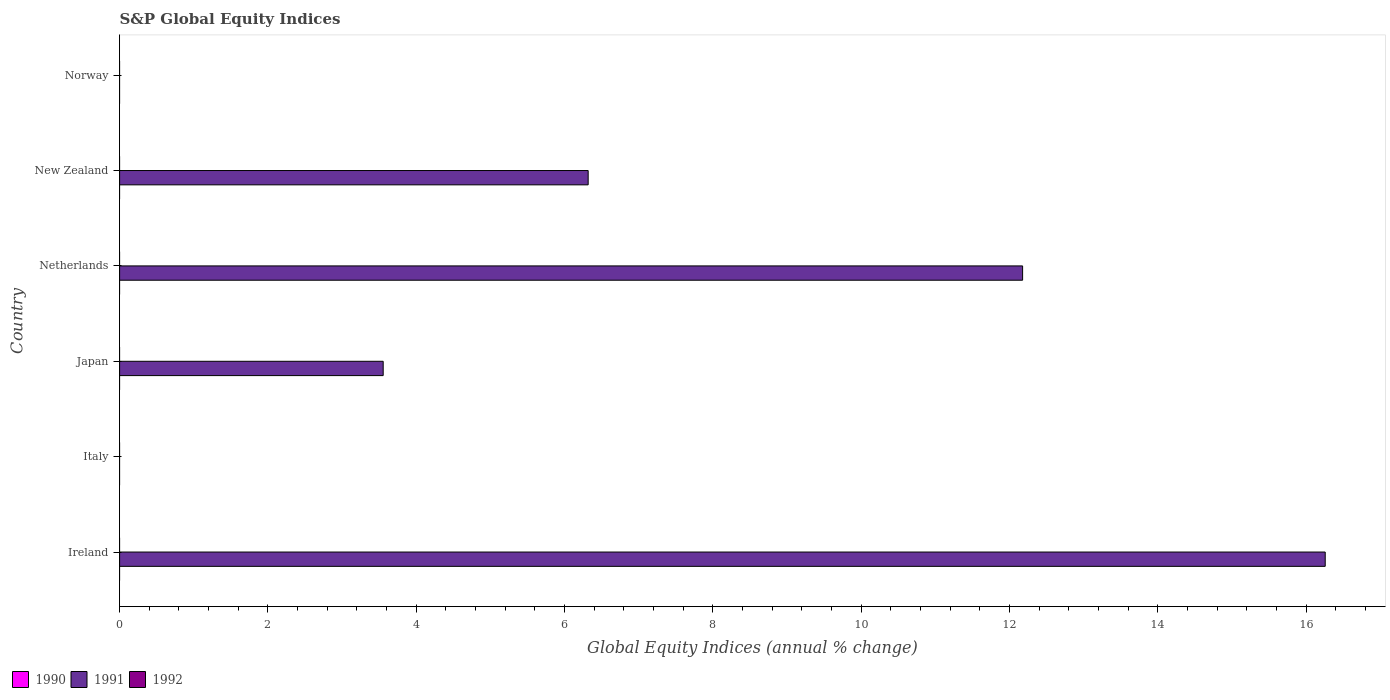How many different coloured bars are there?
Provide a short and direct response. 1. Are the number of bars on each tick of the Y-axis equal?
Give a very brief answer. No. How many bars are there on the 5th tick from the bottom?
Provide a succinct answer. 1. What is the label of the 2nd group of bars from the top?
Give a very brief answer. New Zealand. What is the global equity indices in 1992 in Japan?
Provide a short and direct response. 0. Across all countries, what is the maximum global equity indices in 1991?
Your answer should be compact. 16.26. Across all countries, what is the minimum global equity indices in 1992?
Ensure brevity in your answer.  0. In which country was the global equity indices in 1991 maximum?
Provide a succinct answer. Ireland. What is the average global equity indices in 1991 per country?
Give a very brief answer. 6.38. Is the global equity indices in 1991 in Netherlands less than that in New Zealand?
Keep it short and to the point. No. What is the difference between the highest and the second highest global equity indices in 1991?
Your response must be concise. 4.08. What is the difference between the highest and the lowest global equity indices in 1991?
Provide a short and direct response. 16.26. Is the sum of the global equity indices in 1991 in Ireland and Japan greater than the maximum global equity indices in 1990 across all countries?
Offer a very short reply. Yes. Is it the case that in every country, the sum of the global equity indices in 1992 and global equity indices in 1991 is greater than the global equity indices in 1990?
Your answer should be compact. No. How many bars are there?
Make the answer very short. 4. What is the difference between two consecutive major ticks on the X-axis?
Provide a short and direct response. 2. Where does the legend appear in the graph?
Provide a short and direct response. Bottom left. How many legend labels are there?
Provide a succinct answer. 3. What is the title of the graph?
Keep it short and to the point. S&P Global Equity Indices. What is the label or title of the X-axis?
Your response must be concise. Global Equity Indices (annual % change). What is the Global Equity Indices (annual % change) of 1991 in Ireland?
Provide a short and direct response. 16.26. What is the Global Equity Indices (annual % change) in 1991 in Italy?
Your response must be concise. 0. What is the Global Equity Indices (annual % change) in 1992 in Italy?
Offer a terse response. 0. What is the Global Equity Indices (annual % change) in 1990 in Japan?
Provide a succinct answer. 0. What is the Global Equity Indices (annual % change) in 1991 in Japan?
Offer a terse response. 3.55. What is the Global Equity Indices (annual % change) of 1992 in Japan?
Your answer should be compact. 0. What is the Global Equity Indices (annual % change) in 1991 in Netherlands?
Your response must be concise. 12.18. What is the Global Equity Indices (annual % change) in 1990 in New Zealand?
Offer a terse response. 0. What is the Global Equity Indices (annual % change) of 1991 in New Zealand?
Make the answer very short. 6.32. What is the Global Equity Indices (annual % change) of 1992 in Norway?
Your answer should be very brief. 0. Across all countries, what is the maximum Global Equity Indices (annual % change) in 1991?
Keep it short and to the point. 16.26. What is the total Global Equity Indices (annual % change) of 1991 in the graph?
Make the answer very short. 38.31. What is the difference between the Global Equity Indices (annual % change) in 1991 in Ireland and that in Japan?
Your response must be concise. 12.7. What is the difference between the Global Equity Indices (annual % change) of 1991 in Ireland and that in Netherlands?
Provide a short and direct response. 4.08. What is the difference between the Global Equity Indices (annual % change) in 1991 in Ireland and that in New Zealand?
Offer a terse response. 9.94. What is the difference between the Global Equity Indices (annual % change) in 1991 in Japan and that in Netherlands?
Your answer should be very brief. -8.62. What is the difference between the Global Equity Indices (annual % change) in 1991 in Japan and that in New Zealand?
Offer a terse response. -2.76. What is the difference between the Global Equity Indices (annual % change) of 1991 in Netherlands and that in New Zealand?
Keep it short and to the point. 5.86. What is the average Global Equity Indices (annual % change) in 1991 per country?
Your response must be concise. 6.38. What is the average Global Equity Indices (annual % change) in 1992 per country?
Provide a succinct answer. 0. What is the ratio of the Global Equity Indices (annual % change) in 1991 in Ireland to that in Japan?
Make the answer very short. 4.57. What is the ratio of the Global Equity Indices (annual % change) of 1991 in Ireland to that in Netherlands?
Give a very brief answer. 1.34. What is the ratio of the Global Equity Indices (annual % change) in 1991 in Ireland to that in New Zealand?
Give a very brief answer. 2.57. What is the ratio of the Global Equity Indices (annual % change) in 1991 in Japan to that in Netherlands?
Give a very brief answer. 0.29. What is the ratio of the Global Equity Indices (annual % change) of 1991 in Japan to that in New Zealand?
Your answer should be very brief. 0.56. What is the ratio of the Global Equity Indices (annual % change) in 1991 in Netherlands to that in New Zealand?
Give a very brief answer. 1.93. What is the difference between the highest and the second highest Global Equity Indices (annual % change) of 1991?
Provide a short and direct response. 4.08. What is the difference between the highest and the lowest Global Equity Indices (annual % change) of 1991?
Your answer should be very brief. 16.26. 